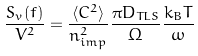Convert formula to latex. <formula><loc_0><loc_0><loc_500><loc_500>\frac { S _ { v } ( f ) } { V ^ { 2 } } = \frac { \langle C ^ { 2 } \rangle } { n _ { i m p } ^ { 2 } } \frac { \pi D _ { T L S } } { \Omega } \frac { k _ { B } T } { \omega }</formula> 